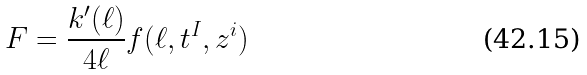<formula> <loc_0><loc_0><loc_500><loc_500>F = \frac { k ^ { \prime } ( \ell ) } { 4 \ell } f ( \ell , t ^ { I } , z ^ { i } )</formula> 